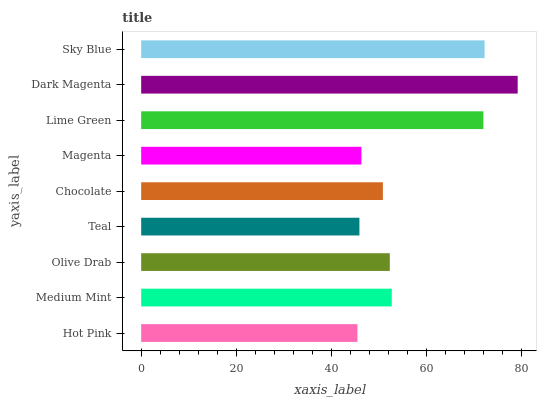Is Hot Pink the minimum?
Answer yes or no. Yes. Is Dark Magenta the maximum?
Answer yes or no. Yes. Is Medium Mint the minimum?
Answer yes or no. No. Is Medium Mint the maximum?
Answer yes or no. No. Is Medium Mint greater than Hot Pink?
Answer yes or no. Yes. Is Hot Pink less than Medium Mint?
Answer yes or no. Yes. Is Hot Pink greater than Medium Mint?
Answer yes or no. No. Is Medium Mint less than Hot Pink?
Answer yes or no. No. Is Olive Drab the high median?
Answer yes or no. Yes. Is Olive Drab the low median?
Answer yes or no. Yes. Is Magenta the high median?
Answer yes or no. No. Is Hot Pink the low median?
Answer yes or no. No. 